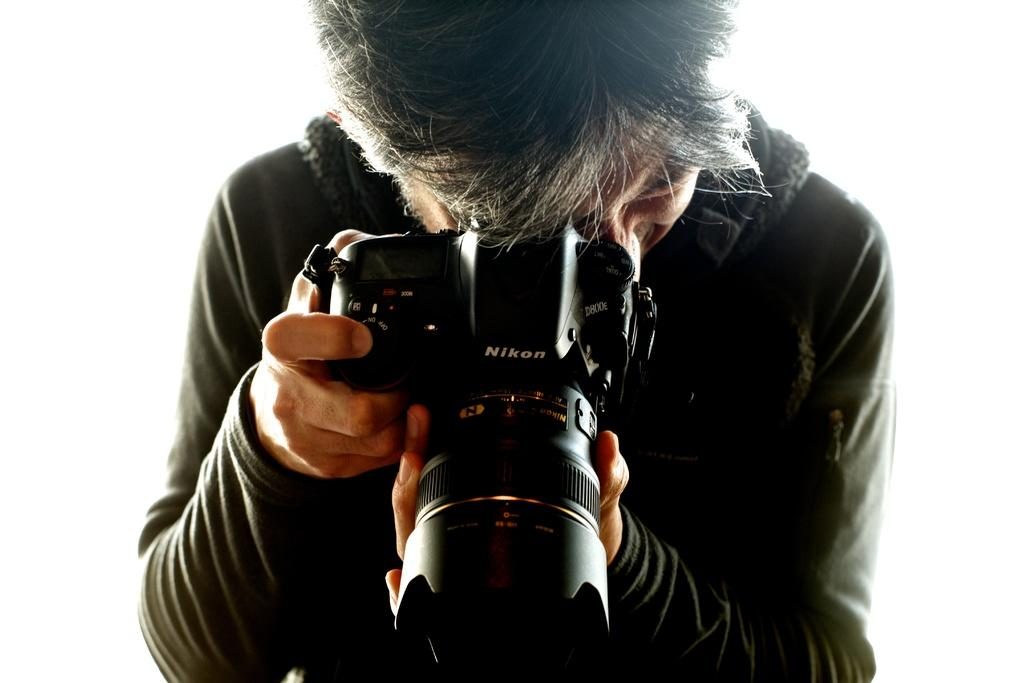What is the main subject of the image? There is a person in the image. What is the person holding in the image? The person is holding a camera. What is the person doing with the camera? The person is taking a snap. What type of meal is the person eating in the image? There is no meal present in the image; the person is holding a camera and taking a snap. What is the relation between the person and the camera in the image? The person is holding the camera, but there is no specific relation mentioned in the image. 